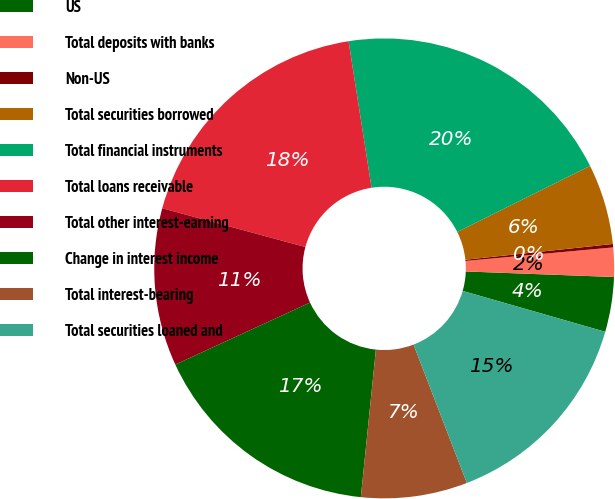<chart> <loc_0><loc_0><loc_500><loc_500><pie_chart><fcel>US<fcel>Total deposits with banks<fcel>Non-US<fcel>Total securities borrowed<fcel>Total financial instruments<fcel>Total loans receivable<fcel>Total other interest-earning<fcel>Change in interest income<fcel>Total interest-bearing<fcel>Total securities loaned and<nl><fcel>3.85%<fcel>2.05%<fcel>0.24%<fcel>5.66%<fcel>20.12%<fcel>18.31%<fcel>11.08%<fcel>16.51%<fcel>7.47%<fcel>14.7%<nl></chart> 